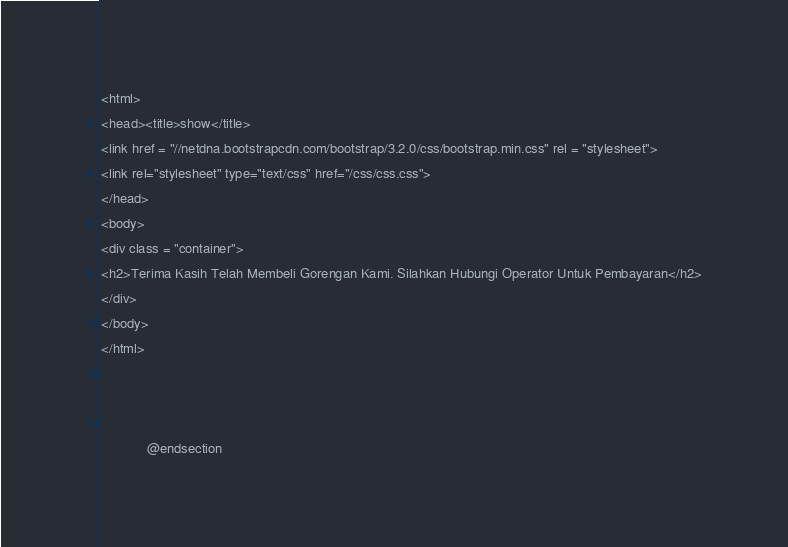<code> <loc_0><loc_0><loc_500><loc_500><_PHP_>
<html>
<head><title>show</title>
<link href = "//netdna.bootstrapcdn.com/bootstrap/3.2.0/css/bootstrap.min.css" rel = "stylesheet">
<link rel="stylesheet" type="text/css" href="/css/css.css">
</head>
<body>
<div class = "container">
<h2>Terima Kasih Telah Membeli Gorengan Kami. Silahkan Hubungi Operator Untuk Pembayaran</h2>
</div>
</body>
</html>

            
	        
	        @endsection</code> 